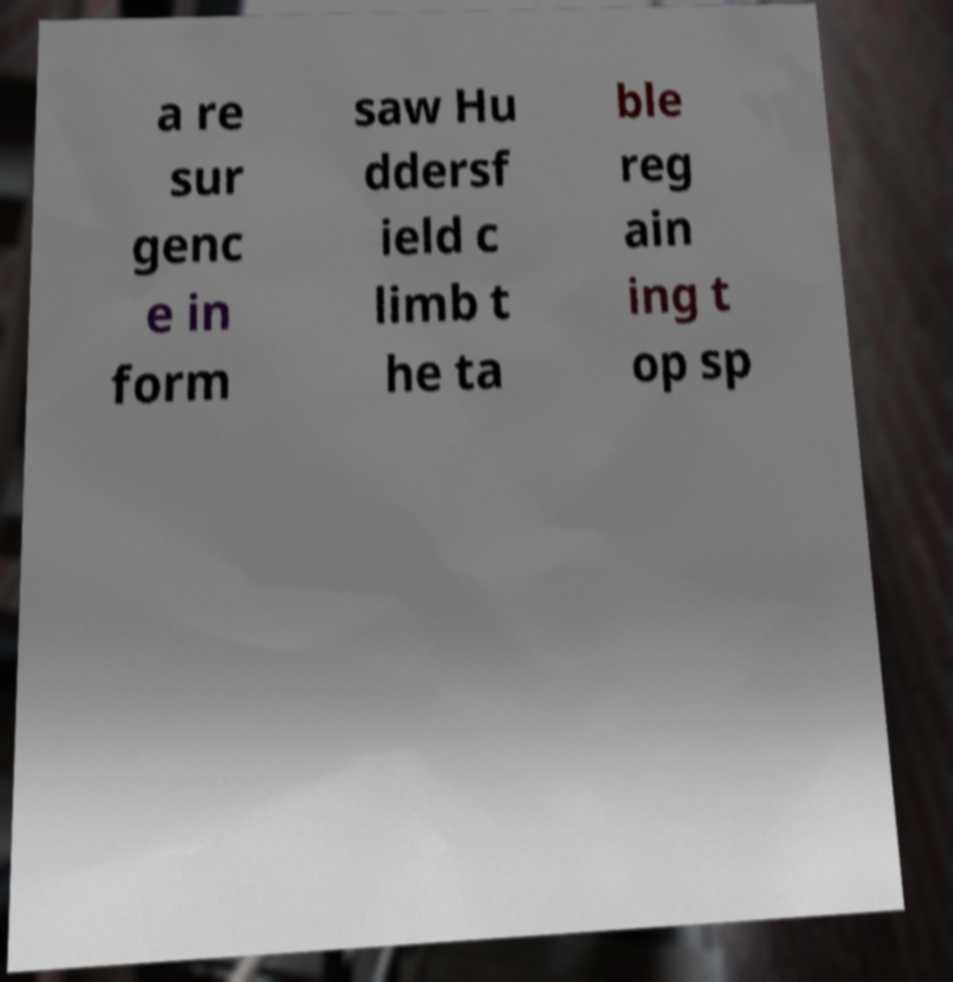Could you assist in decoding the text presented in this image and type it out clearly? a re sur genc e in form saw Hu ddersf ield c limb t he ta ble reg ain ing t op sp 